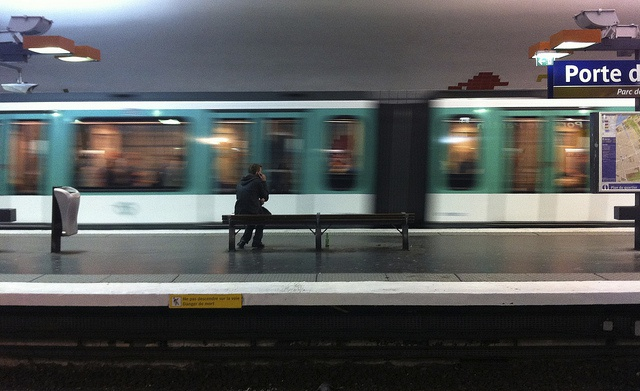Describe the objects in this image and their specific colors. I can see train in white, black, gray, lightgray, and teal tones, bench in white, black, gray, darkgray, and lightgray tones, people in ivory, black, gray, and darkblue tones, and cell phone in ivory and black tones in this image. 